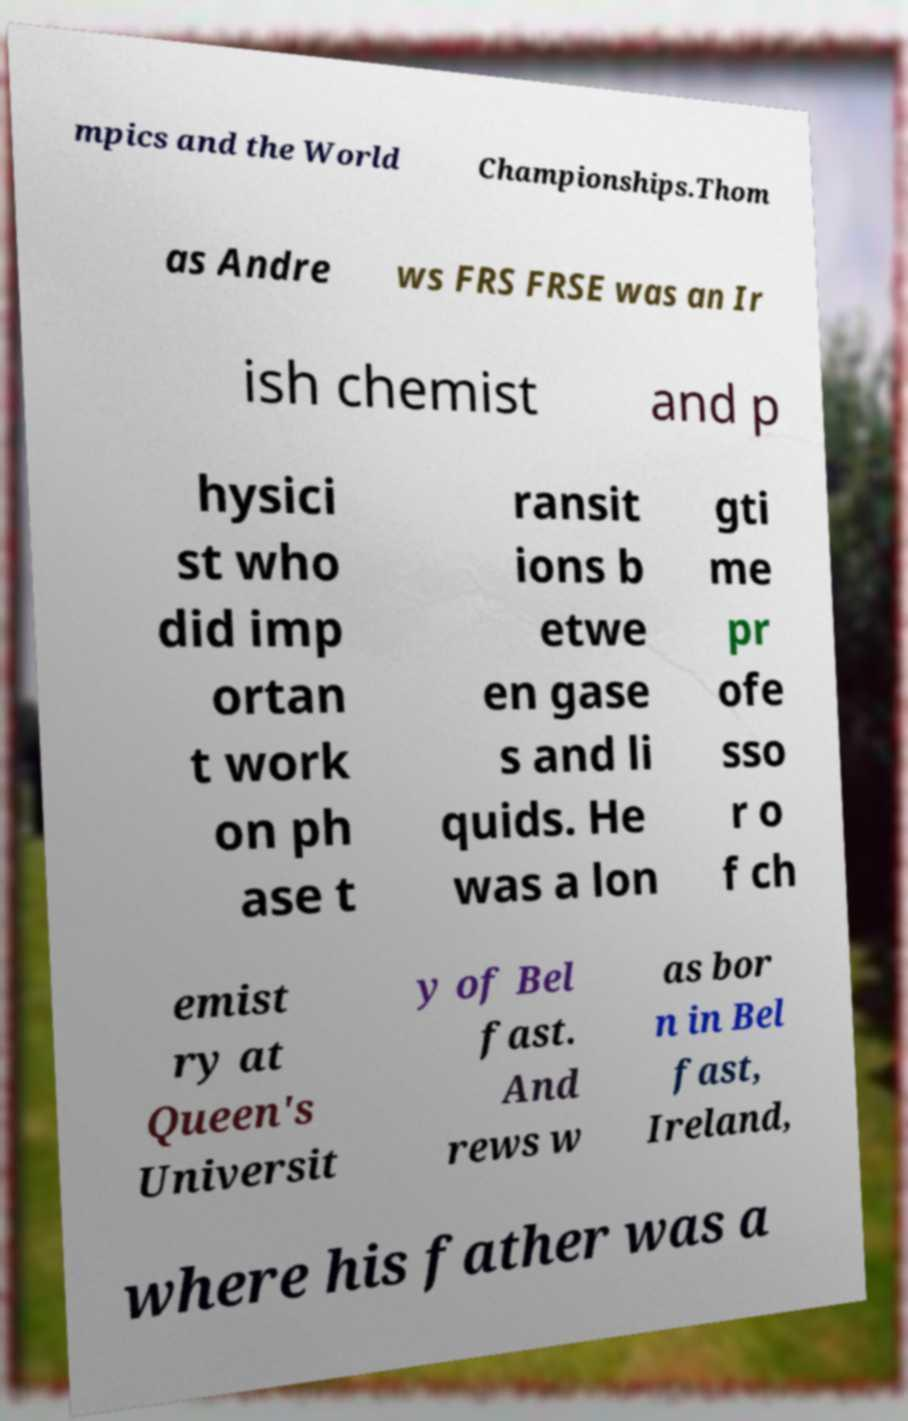Could you assist in decoding the text presented in this image and type it out clearly? mpics and the World Championships.Thom as Andre ws FRS FRSE was an Ir ish chemist and p hysici st who did imp ortan t work on ph ase t ransit ions b etwe en gase s and li quids. He was a lon gti me pr ofe sso r o f ch emist ry at Queen's Universit y of Bel fast. And rews w as bor n in Bel fast, Ireland, where his father was a 